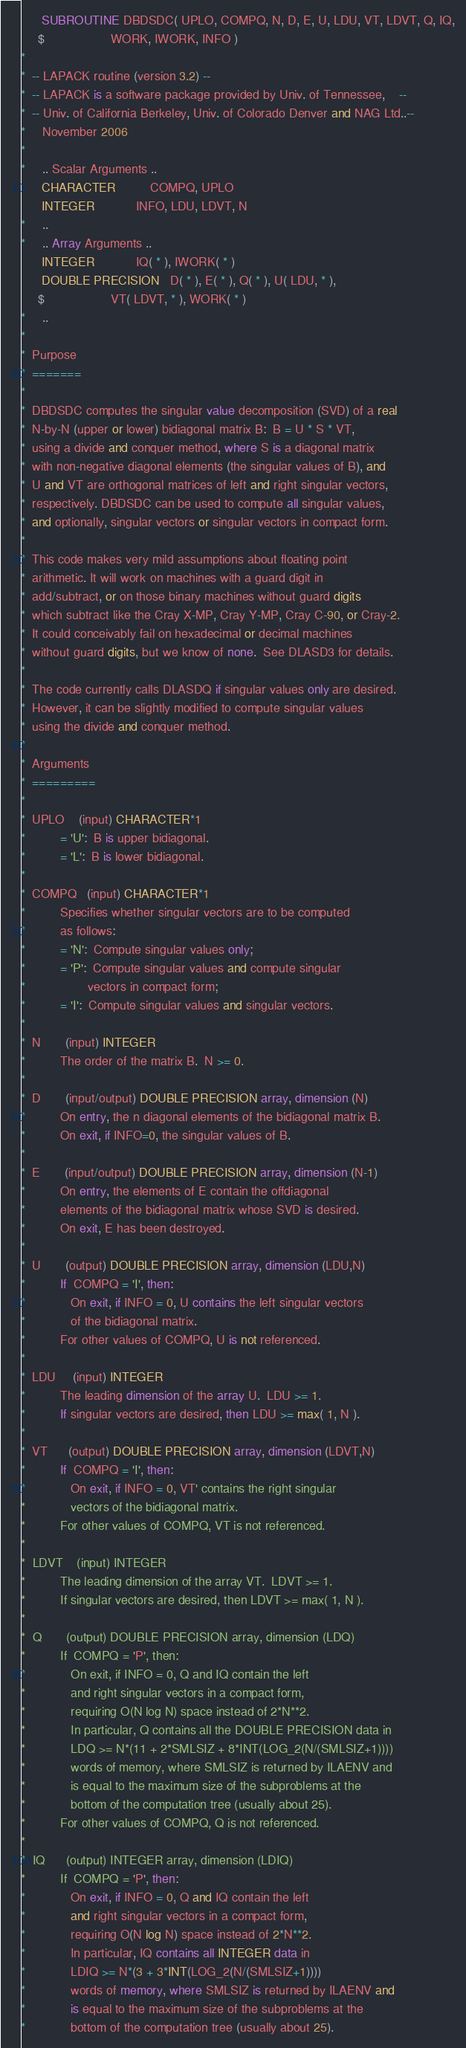<code> <loc_0><loc_0><loc_500><loc_500><_FORTRAN_>      SUBROUTINE DBDSDC( UPLO, COMPQ, N, D, E, U, LDU, VT, LDVT, Q, IQ,
     $                   WORK, IWORK, INFO )
*
*  -- LAPACK routine (version 3.2) --
*  -- LAPACK is a software package provided by Univ. of Tennessee,    --
*  -- Univ. of California Berkeley, Univ. of Colorado Denver and NAG Ltd..--
*     November 2006
*
*     .. Scalar Arguments ..
      CHARACTER          COMPQ, UPLO
      INTEGER            INFO, LDU, LDVT, N
*     ..
*     .. Array Arguments ..
      INTEGER            IQ( * ), IWORK( * )
      DOUBLE PRECISION   D( * ), E( * ), Q( * ), U( LDU, * ),
     $                   VT( LDVT, * ), WORK( * )
*     ..
*
*  Purpose
*  =======
*
*  DBDSDC computes the singular value decomposition (SVD) of a real
*  N-by-N (upper or lower) bidiagonal matrix B:  B = U * S * VT,
*  using a divide and conquer method, where S is a diagonal matrix
*  with non-negative diagonal elements (the singular values of B), and
*  U and VT are orthogonal matrices of left and right singular vectors,
*  respectively. DBDSDC can be used to compute all singular values,
*  and optionally, singular vectors or singular vectors in compact form.
*
*  This code makes very mild assumptions about floating point
*  arithmetic. It will work on machines with a guard digit in
*  add/subtract, or on those binary machines without guard digits
*  which subtract like the Cray X-MP, Cray Y-MP, Cray C-90, or Cray-2.
*  It could conceivably fail on hexadecimal or decimal machines
*  without guard digits, but we know of none.  See DLASD3 for details.
*
*  The code currently calls DLASDQ if singular values only are desired.
*  However, it can be slightly modified to compute singular values
*  using the divide and conquer method.
*
*  Arguments
*  =========
*
*  UPLO    (input) CHARACTER*1
*          = 'U':  B is upper bidiagonal.
*          = 'L':  B is lower bidiagonal.
*
*  COMPQ   (input) CHARACTER*1
*          Specifies whether singular vectors are to be computed
*          as follows:
*          = 'N':  Compute singular values only;
*          = 'P':  Compute singular values and compute singular
*                  vectors in compact form;
*          = 'I':  Compute singular values and singular vectors.
*
*  N       (input) INTEGER
*          The order of the matrix B.  N >= 0.
*
*  D       (input/output) DOUBLE PRECISION array, dimension (N)
*          On entry, the n diagonal elements of the bidiagonal matrix B.
*          On exit, if INFO=0, the singular values of B.
*
*  E       (input/output) DOUBLE PRECISION array, dimension (N-1)
*          On entry, the elements of E contain the offdiagonal
*          elements of the bidiagonal matrix whose SVD is desired.
*          On exit, E has been destroyed.
*
*  U       (output) DOUBLE PRECISION array, dimension (LDU,N)
*          If  COMPQ = 'I', then:
*             On exit, if INFO = 0, U contains the left singular vectors
*             of the bidiagonal matrix.
*          For other values of COMPQ, U is not referenced.
*
*  LDU     (input) INTEGER
*          The leading dimension of the array U.  LDU >= 1.
*          If singular vectors are desired, then LDU >= max( 1, N ).
*
*  VT      (output) DOUBLE PRECISION array, dimension (LDVT,N)
*          If  COMPQ = 'I', then:
*             On exit, if INFO = 0, VT' contains the right singular
*             vectors of the bidiagonal matrix.
*          For other values of COMPQ, VT is not referenced.
*
*  LDVT    (input) INTEGER
*          The leading dimension of the array VT.  LDVT >= 1.
*          If singular vectors are desired, then LDVT >= max( 1, N ).
*
*  Q       (output) DOUBLE PRECISION array, dimension (LDQ)
*          If  COMPQ = 'P', then:
*             On exit, if INFO = 0, Q and IQ contain the left
*             and right singular vectors in a compact form,
*             requiring O(N log N) space instead of 2*N**2.
*             In particular, Q contains all the DOUBLE PRECISION data in
*             LDQ >= N*(11 + 2*SMLSIZ + 8*INT(LOG_2(N/(SMLSIZ+1))))
*             words of memory, where SMLSIZ is returned by ILAENV and
*             is equal to the maximum size of the subproblems at the
*             bottom of the computation tree (usually about 25).
*          For other values of COMPQ, Q is not referenced.
*
*  IQ      (output) INTEGER array, dimension (LDIQ)
*          If  COMPQ = 'P', then:
*             On exit, if INFO = 0, Q and IQ contain the left
*             and right singular vectors in a compact form,
*             requiring O(N log N) space instead of 2*N**2.
*             In particular, IQ contains all INTEGER data in
*             LDIQ >= N*(3 + 3*INT(LOG_2(N/(SMLSIZ+1))))
*             words of memory, where SMLSIZ is returned by ILAENV and
*             is equal to the maximum size of the subproblems at the
*             bottom of the computation tree (usually about 25).</code> 